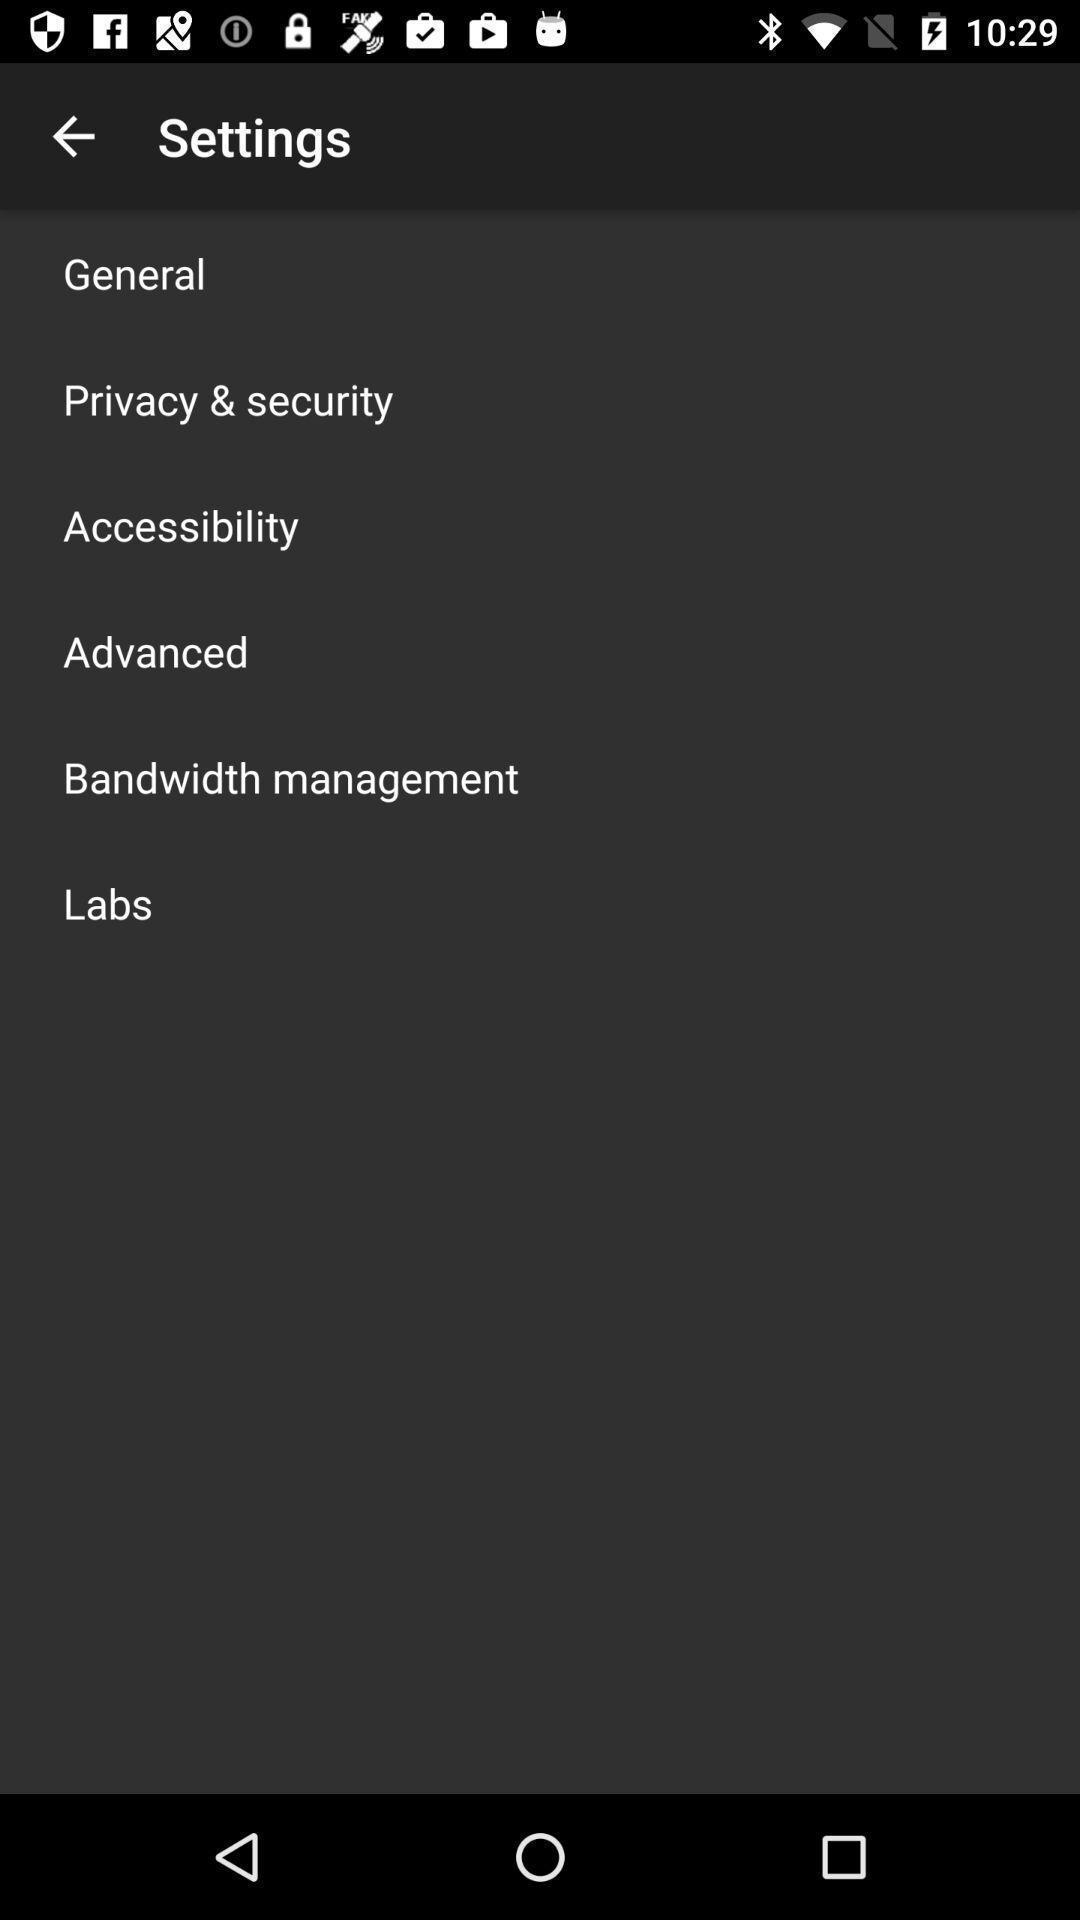Tell me about the visual elements in this screen capture. Settings tab in the application with different options. 